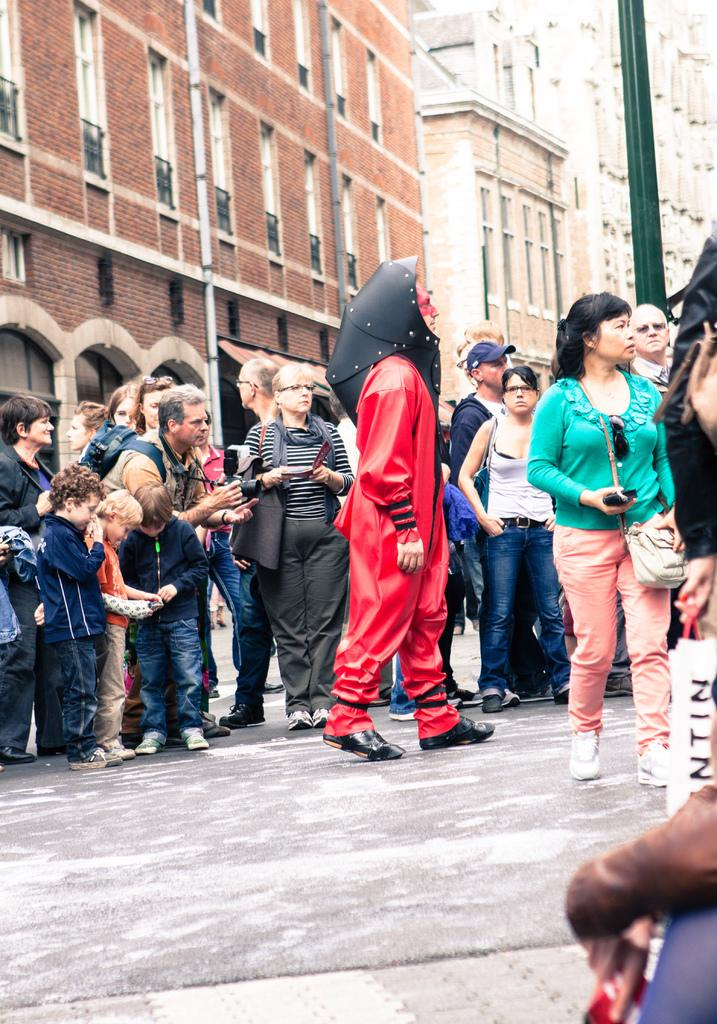What is the person in the image wearing? There is a person in a fancy dress in the image. Where is the person standing? The person is standing on the road. Are there any other people in the image? Yes, there is a group of people in the image. What can be seen in the background of the image? There are buildings in the background of the image. Is there a hose being used by the person in the fancy dress in the image? No, there is no hose present in the image. 